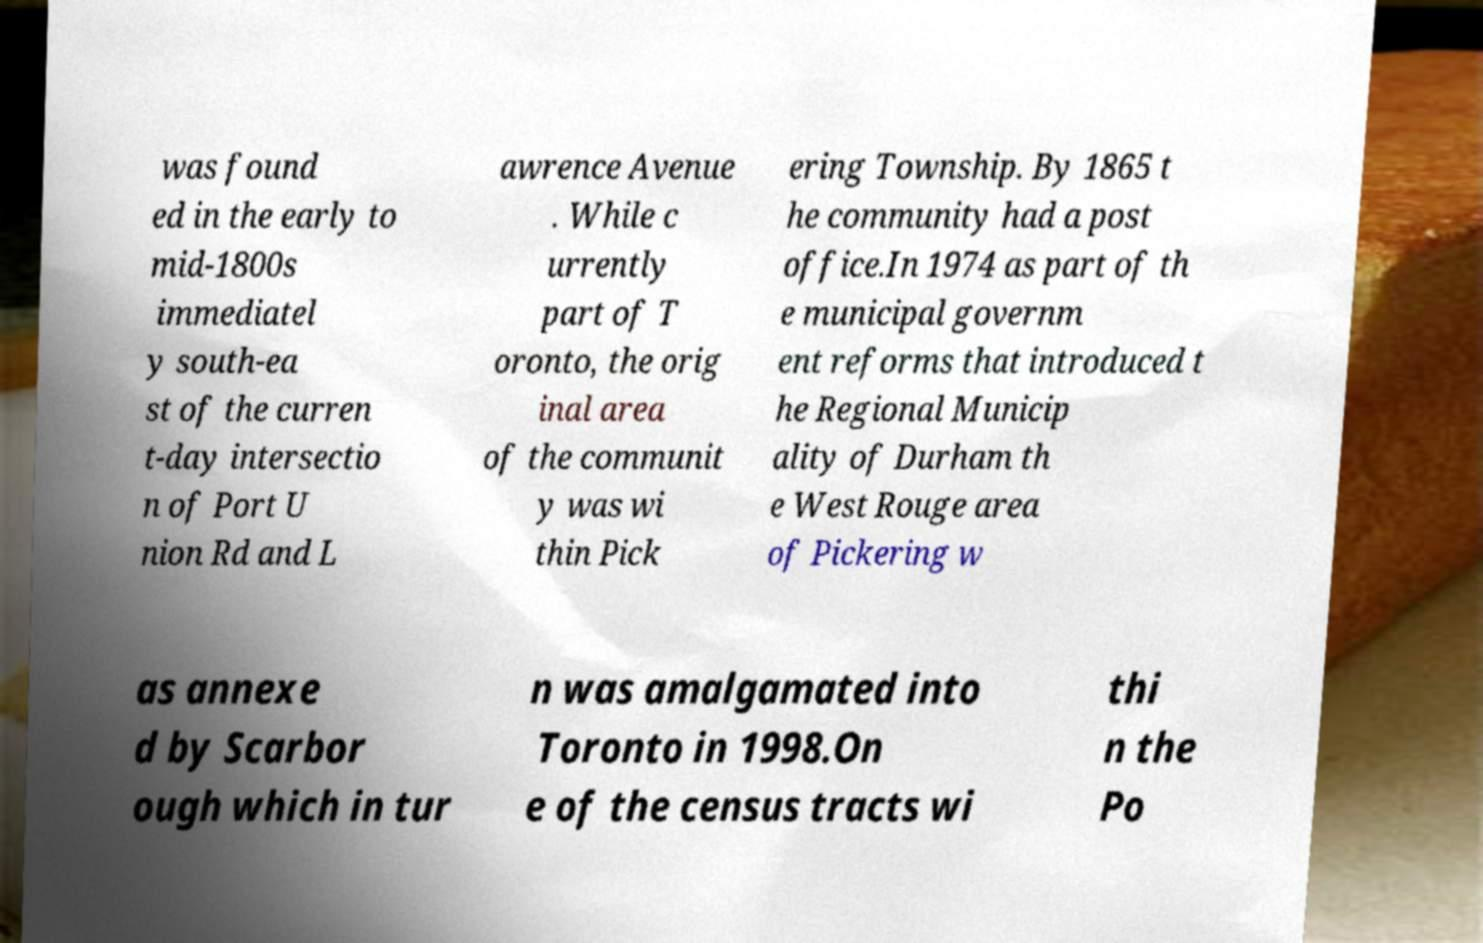Can you accurately transcribe the text from the provided image for me? was found ed in the early to mid-1800s immediatel y south-ea st of the curren t-day intersectio n of Port U nion Rd and L awrence Avenue . While c urrently part of T oronto, the orig inal area of the communit y was wi thin Pick ering Township. By 1865 t he community had a post office.In 1974 as part of th e municipal governm ent reforms that introduced t he Regional Municip ality of Durham th e West Rouge area of Pickering w as annexe d by Scarbor ough which in tur n was amalgamated into Toronto in 1998.On e of the census tracts wi thi n the Po 